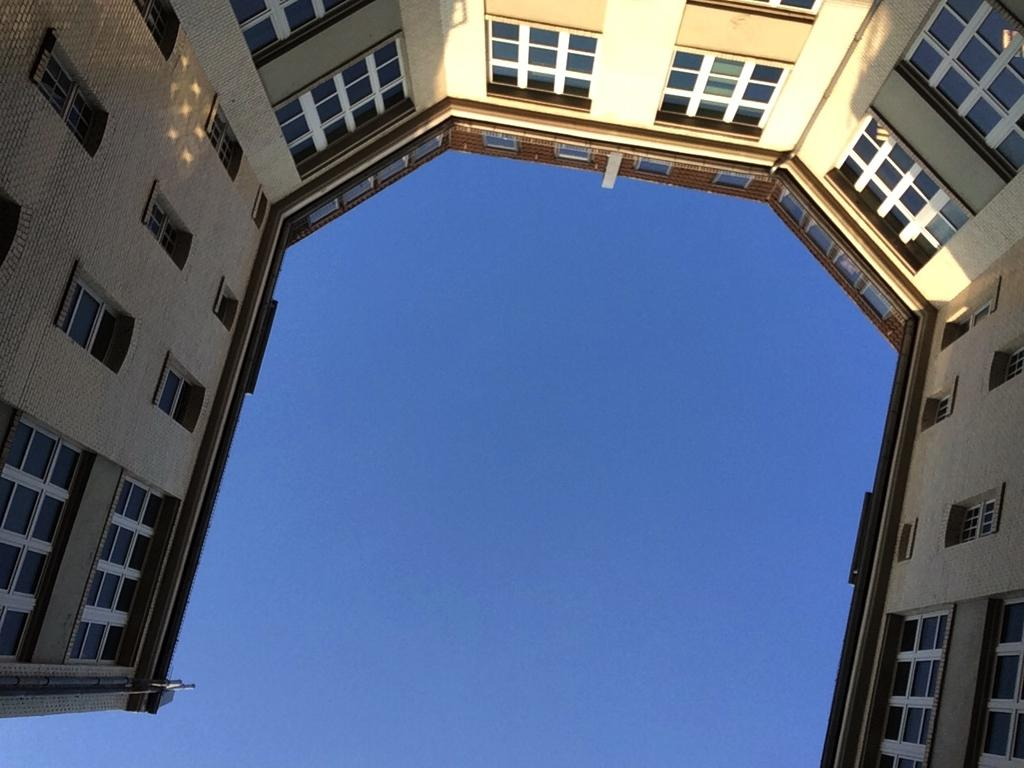What type of structure is present in the image? There is a building in the image. What architectural feature can be seen on the building? There are windows visible on the building. What is visible in the background of the image? The sky is visible in the image. What is the color of the sky in the image? The color of the sky is blue. Where is the fork being used in the image? There is no fork present in the image. What type of cream is being served at the meeting in the image? There is no meeting or cream present in the image. 